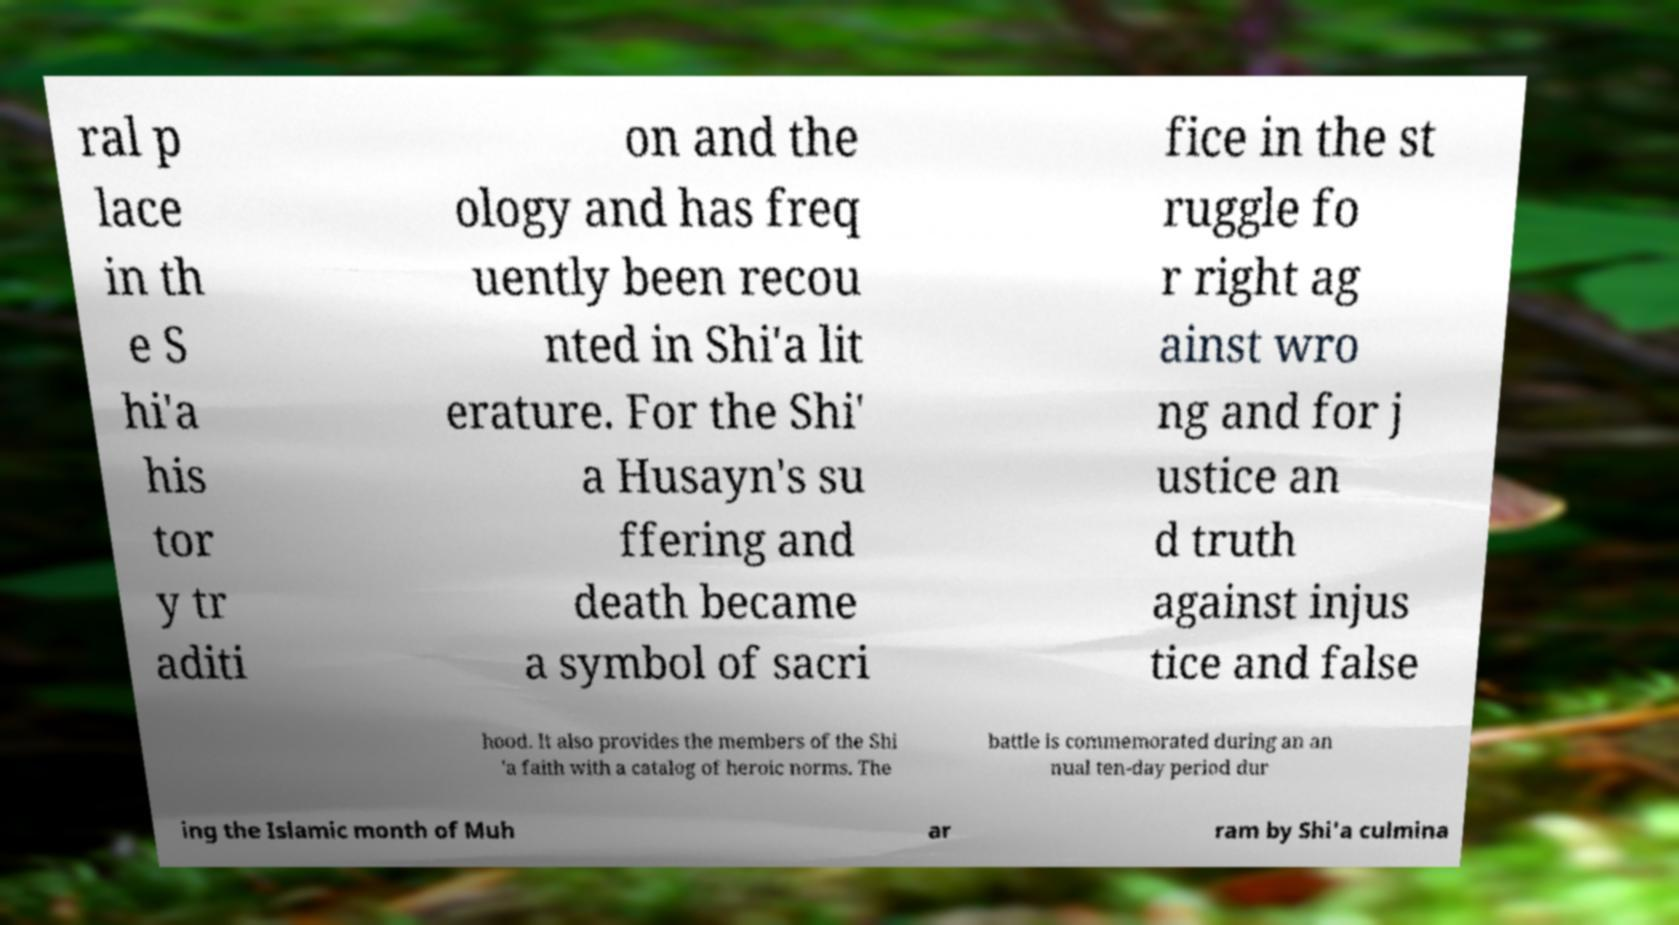Could you extract and type out the text from this image? ral p lace in th e S hi'a his tor y tr aditi on and the ology and has freq uently been recou nted in Shi'a lit erature. For the Shi' a Husayn's su ffering and death became a symbol of sacri fice in the st ruggle fo r right ag ainst wro ng and for j ustice an d truth against injus tice and false hood. It also provides the members of the Shi 'a faith with a catalog of heroic norms. The battle is commemorated during an an nual ten-day period dur ing the Islamic month of Muh ar ram by Shi'a culmina 